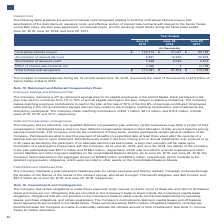According to Lam Research Corporation's financial document, What is the cause of the increase in interest expense during the 12 months ended June 30, 2019? the issuance of $2.5 billion of Senior Notes in March 2019. The document states: "s ended June 30, 2019, is primarily the result of the issuance of $2.5 billion of Senior Notes in March 2019...." Also, What is total interest cost recognised in 2019? According to the financial document, $110,161 (in thousands). The relevant text states: "Total interest cost recognized $ 110,161 $ 91,353 $ 115,726..." Also, What is the contractual interest coupon in 2018? According to the financial document, $77,091 (in thousands). The relevant text states: "Contractual interest coupon $ 100,712 $ 77,091 $ 95,195..." Also, can you calculate: What is the percentage change in the Amortization of interest discount from 2018 to 2019? To answer this question, I need to perform calculations using the financial data. The calculation is: (3,937-12,225)/12,225, which equals -67.8 (percentage). This is based on the information: "Amortization of interest discount 3,937 12,225 22,873 Amortization of interest discount 3,937 12,225 22,873..." The key data points involved are: 12,225, 3,937. Also, can you calculate: What is the percentage change in the amortization of issuance costs from 2018 to 2019? To answer this question, I need to perform calculations using the financial data. The calculation is: (1,426-2,034)/2,034, which equals -29.89 (percentage). This is based on the information: "Amortization of issuance costs 1,426 2,034 2,414 Amortization of issuance costs 1,426 2,034 2,414..." The key data points involved are: 1,426, 2,034. Also, can you calculate: What is the percentage change in the total interest cost recognised from 2018 to 2019? To answer this question, I need to perform calculations using the financial data. The calculation is: (110,161-91,353)/91,353, which equals 20.59 (percentage). This is based on the information: "Total interest cost recognized $ 110,161 $ 91,353 $ 115,726 Total interest cost recognized $ 110,161 $ 91,353 $ 115,726..." The key data points involved are: 110,161, 91,353. 